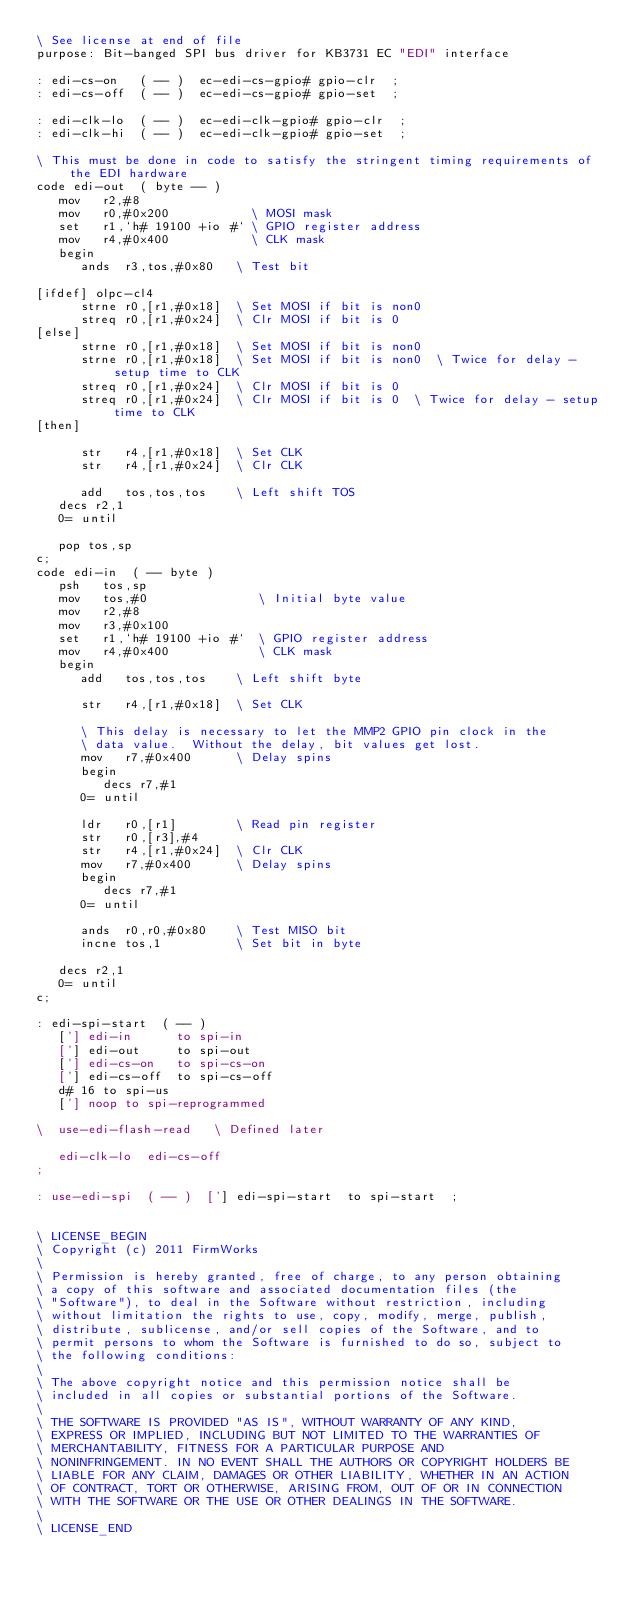<code> <loc_0><loc_0><loc_500><loc_500><_Forth_>\ See license at end of file
purpose: Bit-banged SPI bus driver for KB3731 EC "EDI" interface

: edi-cs-on   ( -- )  ec-edi-cs-gpio# gpio-clr  ;
: edi-cs-off  ( -- )  ec-edi-cs-gpio# gpio-set  ;

: edi-clk-lo  ( -- )  ec-edi-clk-gpio# gpio-clr  ;
: edi-clk-hi  ( -- )  ec-edi-clk-gpio# gpio-set  ;

\ This must be done in code to satisfy the stringent timing requirements of the EDI hardware
code edi-out  ( byte -- )
   mov   r2,#8
   mov   r0,#0x200           \ MOSI mask
   set   r1,`h# 19100 +io #` \ GPIO register address
   mov   r4,#0x400           \ CLK mask
   begin
      ands  r3,tos,#0x80   \ Test bit

[ifdef] olpc-cl4
      strne r0,[r1,#0x18]  \ Set MOSI if bit is non0
      streq r0,[r1,#0x24]  \ Clr MOSI if bit is 0
[else]
      strne r0,[r1,#0x18]  \ Set MOSI if bit is non0
      strne r0,[r1,#0x18]  \ Set MOSI if bit is non0  \ Twice for delay - setup time to CLK
      streq r0,[r1,#0x24]  \ Clr MOSI if bit is 0
      streq r0,[r1,#0x24]  \ Clr MOSI if bit is 0  \ Twice for delay - setup time to CLK
[then]

      str   r4,[r1,#0x18]  \ Set CLK
      str   r4,[r1,#0x24]  \ Clr CLK

      add   tos,tos,tos    \ Left shift TOS      
   decs r2,1
   0= until

   pop tos,sp
c;
code edi-in  ( -- byte )
   psh   tos,sp
   mov   tos,#0               \ Initial byte value
   mov   r2,#8
   mov   r3,#0x100
   set   r1,`h# 19100 +io #`  \ GPIO register address
   mov   r4,#0x400            \ CLK mask
   begin
      add   tos,tos,tos    \ Left shift byte

      str   r4,[r1,#0x18]  \ Set CLK

      \ This delay is necessary to let the MMP2 GPIO pin clock in the
      \ data value.  Without the delay, bit values get lost.
      mov   r7,#0x400      \ Delay spins
      begin
         decs r7,#1
      0= until

      ldr   r0,[r1]        \ Read pin register
      str   r0,[r3],#4
      str   r4,[r1,#0x24]  \ Clr CLK
      mov   r7,#0x400      \ Delay spins
      begin
         decs r7,#1
      0= until

      ands  r0,r0,#0x80    \ Test MISO bit
      incne tos,1          \ Set bit in byte

   decs r2,1
   0= until
c;

: edi-spi-start  ( -- )
   ['] edi-in      to spi-in
   ['] edi-out     to spi-out
   ['] edi-cs-on   to spi-cs-on
   ['] edi-cs-off  to spi-cs-off
   d# 16 to spi-us
   ['] noop to spi-reprogrammed

\  use-edi-flash-read   \ Defined later

   edi-clk-lo  edi-cs-off
;

: use-edi-spi  ( -- )  ['] edi-spi-start  to spi-start  ;


\ LICENSE_BEGIN
\ Copyright (c) 2011 FirmWorks
\ 
\ Permission is hereby granted, free of charge, to any person obtaining
\ a copy of this software and associated documentation files (the
\ "Software"), to deal in the Software without restriction, including
\ without limitation the rights to use, copy, modify, merge, publish,
\ distribute, sublicense, and/or sell copies of the Software, and to
\ permit persons to whom the Software is furnished to do so, subject to
\ the following conditions:
\ 
\ The above copyright notice and this permission notice shall be
\ included in all copies or substantial portions of the Software.
\ 
\ THE SOFTWARE IS PROVIDED "AS IS", WITHOUT WARRANTY OF ANY KIND,
\ EXPRESS OR IMPLIED, INCLUDING BUT NOT LIMITED TO THE WARRANTIES OF
\ MERCHANTABILITY, FITNESS FOR A PARTICULAR PURPOSE AND
\ NONINFRINGEMENT. IN NO EVENT SHALL THE AUTHORS OR COPYRIGHT HOLDERS BE
\ LIABLE FOR ANY CLAIM, DAMAGES OR OTHER LIABILITY, WHETHER IN AN ACTION
\ OF CONTRACT, TORT OR OTHERWISE, ARISING FROM, OUT OF OR IN CONNECTION
\ WITH THE SOFTWARE OR THE USE OR OTHER DEALINGS IN THE SOFTWARE.
\
\ LICENSE_END
</code> 